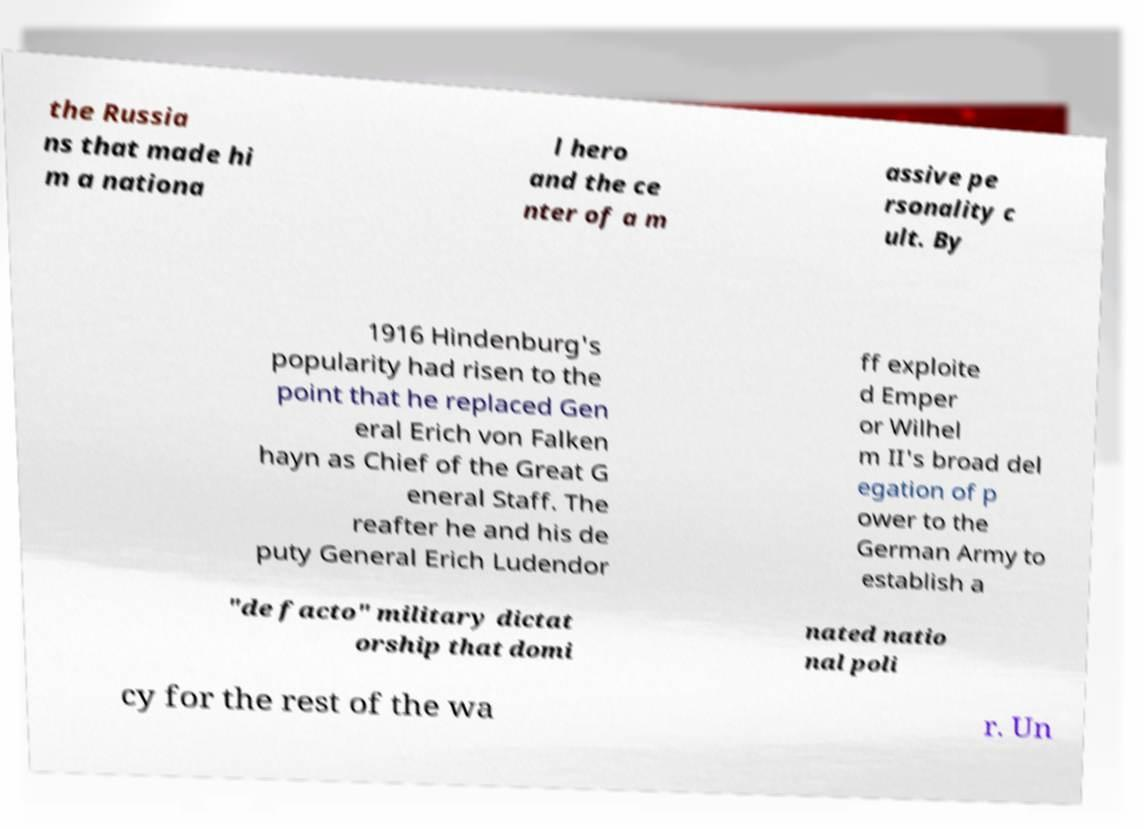There's text embedded in this image that I need extracted. Can you transcribe it verbatim? the Russia ns that made hi m a nationa l hero and the ce nter of a m assive pe rsonality c ult. By 1916 Hindenburg's popularity had risen to the point that he replaced Gen eral Erich von Falken hayn as Chief of the Great G eneral Staff. The reafter he and his de puty General Erich Ludendor ff exploite d Emper or Wilhel m II's broad del egation of p ower to the German Army to establish a "de facto" military dictat orship that domi nated natio nal poli cy for the rest of the wa r. Un 